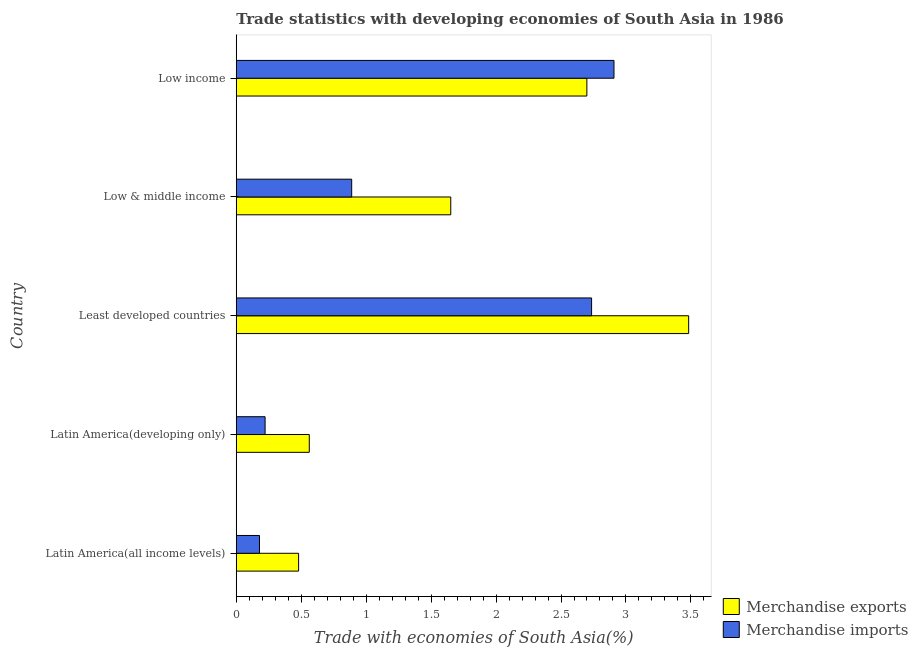Are the number of bars per tick equal to the number of legend labels?
Provide a short and direct response. Yes. Are the number of bars on each tick of the Y-axis equal?
Give a very brief answer. Yes. How many bars are there on the 5th tick from the bottom?
Your response must be concise. 2. What is the label of the 4th group of bars from the top?
Your answer should be compact. Latin America(developing only). What is the merchandise imports in Low income?
Your answer should be compact. 2.91. Across all countries, what is the maximum merchandise imports?
Make the answer very short. 2.91. Across all countries, what is the minimum merchandise imports?
Your answer should be compact. 0.18. In which country was the merchandise exports maximum?
Offer a very short reply. Least developed countries. In which country was the merchandise exports minimum?
Provide a short and direct response. Latin America(all income levels). What is the total merchandise imports in the graph?
Provide a succinct answer. 6.93. What is the difference between the merchandise exports in Least developed countries and that in Low income?
Your answer should be very brief. 0.78. What is the difference between the merchandise imports in Latin America(all income levels) and the merchandise exports in Low income?
Your answer should be very brief. -2.52. What is the average merchandise exports per country?
Offer a terse response. 1.77. What is the difference between the merchandise imports and merchandise exports in Latin America(all income levels)?
Provide a short and direct response. -0.3. In how many countries, is the merchandise imports greater than 2 %?
Your answer should be very brief. 2. What is the difference between the highest and the second highest merchandise imports?
Your answer should be compact. 0.17. What is the difference between the highest and the lowest merchandise imports?
Keep it short and to the point. 2.73. What does the 2nd bar from the top in Low & middle income represents?
Ensure brevity in your answer.  Merchandise exports. What does the 2nd bar from the bottom in Least developed countries represents?
Offer a terse response. Merchandise imports. How many bars are there?
Keep it short and to the point. 10. Are all the bars in the graph horizontal?
Give a very brief answer. Yes. How many countries are there in the graph?
Offer a terse response. 5. What is the difference between two consecutive major ticks on the X-axis?
Your response must be concise. 0.5. Are the values on the major ticks of X-axis written in scientific E-notation?
Your answer should be compact. No. Does the graph contain any zero values?
Provide a succinct answer. No. Does the graph contain grids?
Your answer should be compact. No. How many legend labels are there?
Your answer should be compact. 2. What is the title of the graph?
Your answer should be very brief. Trade statistics with developing economies of South Asia in 1986. What is the label or title of the X-axis?
Your answer should be very brief. Trade with economies of South Asia(%). What is the Trade with economies of South Asia(%) in Merchandise exports in Latin America(all income levels)?
Your response must be concise. 0.48. What is the Trade with economies of South Asia(%) in Merchandise imports in Latin America(all income levels)?
Your response must be concise. 0.18. What is the Trade with economies of South Asia(%) of Merchandise exports in Latin America(developing only)?
Make the answer very short. 0.56. What is the Trade with economies of South Asia(%) of Merchandise imports in Latin America(developing only)?
Your answer should be compact. 0.22. What is the Trade with economies of South Asia(%) of Merchandise exports in Least developed countries?
Offer a very short reply. 3.48. What is the Trade with economies of South Asia(%) of Merchandise imports in Least developed countries?
Make the answer very short. 2.74. What is the Trade with economies of South Asia(%) in Merchandise exports in Low & middle income?
Your answer should be compact. 1.65. What is the Trade with economies of South Asia(%) in Merchandise imports in Low & middle income?
Your answer should be very brief. 0.89. What is the Trade with economies of South Asia(%) of Merchandise exports in Low income?
Your response must be concise. 2.7. What is the Trade with economies of South Asia(%) of Merchandise imports in Low income?
Your response must be concise. 2.91. Across all countries, what is the maximum Trade with economies of South Asia(%) in Merchandise exports?
Offer a very short reply. 3.48. Across all countries, what is the maximum Trade with economies of South Asia(%) of Merchandise imports?
Provide a short and direct response. 2.91. Across all countries, what is the minimum Trade with economies of South Asia(%) in Merchandise exports?
Make the answer very short. 0.48. Across all countries, what is the minimum Trade with economies of South Asia(%) in Merchandise imports?
Keep it short and to the point. 0.18. What is the total Trade with economies of South Asia(%) of Merchandise exports in the graph?
Your answer should be very brief. 8.88. What is the total Trade with economies of South Asia(%) of Merchandise imports in the graph?
Ensure brevity in your answer.  6.93. What is the difference between the Trade with economies of South Asia(%) of Merchandise exports in Latin America(all income levels) and that in Latin America(developing only)?
Make the answer very short. -0.08. What is the difference between the Trade with economies of South Asia(%) in Merchandise imports in Latin America(all income levels) and that in Latin America(developing only)?
Ensure brevity in your answer.  -0.04. What is the difference between the Trade with economies of South Asia(%) of Merchandise exports in Latin America(all income levels) and that in Least developed countries?
Give a very brief answer. -3. What is the difference between the Trade with economies of South Asia(%) in Merchandise imports in Latin America(all income levels) and that in Least developed countries?
Offer a very short reply. -2.56. What is the difference between the Trade with economies of South Asia(%) of Merchandise exports in Latin America(all income levels) and that in Low & middle income?
Ensure brevity in your answer.  -1.17. What is the difference between the Trade with economies of South Asia(%) in Merchandise imports in Latin America(all income levels) and that in Low & middle income?
Make the answer very short. -0.71. What is the difference between the Trade with economies of South Asia(%) in Merchandise exports in Latin America(all income levels) and that in Low income?
Offer a very short reply. -2.22. What is the difference between the Trade with economies of South Asia(%) in Merchandise imports in Latin America(all income levels) and that in Low income?
Make the answer very short. -2.73. What is the difference between the Trade with economies of South Asia(%) of Merchandise exports in Latin America(developing only) and that in Least developed countries?
Your response must be concise. -2.92. What is the difference between the Trade with economies of South Asia(%) in Merchandise imports in Latin America(developing only) and that in Least developed countries?
Your answer should be very brief. -2.51. What is the difference between the Trade with economies of South Asia(%) in Merchandise exports in Latin America(developing only) and that in Low & middle income?
Give a very brief answer. -1.09. What is the difference between the Trade with economies of South Asia(%) in Merchandise imports in Latin America(developing only) and that in Low & middle income?
Provide a succinct answer. -0.67. What is the difference between the Trade with economies of South Asia(%) of Merchandise exports in Latin America(developing only) and that in Low income?
Make the answer very short. -2.14. What is the difference between the Trade with economies of South Asia(%) of Merchandise imports in Latin America(developing only) and that in Low income?
Offer a terse response. -2.69. What is the difference between the Trade with economies of South Asia(%) in Merchandise exports in Least developed countries and that in Low & middle income?
Provide a succinct answer. 1.83. What is the difference between the Trade with economies of South Asia(%) of Merchandise imports in Least developed countries and that in Low & middle income?
Make the answer very short. 1.85. What is the difference between the Trade with economies of South Asia(%) in Merchandise exports in Least developed countries and that in Low income?
Provide a succinct answer. 0.78. What is the difference between the Trade with economies of South Asia(%) of Merchandise imports in Least developed countries and that in Low income?
Keep it short and to the point. -0.17. What is the difference between the Trade with economies of South Asia(%) of Merchandise exports in Low & middle income and that in Low income?
Your answer should be very brief. -1.05. What is the difference between the Trade with economies of South Asia(%) of Merchandise imports in Low & middle income and that in Low income?
Keep it short and to the point. -2.02. What is the difference between the Trade with economies of South Asia(%) of Merchandise exports in Latin America(all income levels) and the Trade with economies of South Asia(%) of Merchandise imports in Latin America(developing only)?
Ensure brevity in your answer.  0.26. What is the difference between the Trade with economies of South Asia(%) in Merchandise exports in Latin America(all income levels) and the Trade with economies of South Asia(%) in Merchandise imports in Least developed countries?
Keep it short and to the point. -2.26. What is the difference between the Trade with economies of South Asia(%) of Merchandise exports in Latin America(all income levels) and the Trade with economies of South Asia(%) of Merchandise imports in Low & middle income?
Your answer should be compact. -0.41. What is the difference between the Trade with economies of South Asia(%) of Merchandise exports in Latin America(all income levels) and the Trade with economies of South Asia(%) of Merchandise imports in Low income?
Make the answer very short. -2.43. What is the difference between the Trade with economies of South Asia(%) of Merchandise exports in Latin America(developing only) and the Trade with economies of South Asia(%) of Merchandise imports in Least developed countries?
Your answer should be compact. -2.17. What is the difference between the Trade with economies of South Asia(%) in Merchandise exports in Latin America(developing only) and the Trade with economies of South Asia(%) in Merchandise imports in Low & middle income?
Your answer should be compact. -0.33. What is the difference between the Trade with economies of South Asia(%) of Merchandise exports in Latin America(developing only) and the Trade with economies of South Asia(%) of Merchandise imports in Low income?
Make the answer very short. -2.35. What is the difference between the Trade with economies of South Asia(%) of Merchandise exports in Least developed countries and the Trade with economies of South Asia(%) of Merchandise imports in Low & middle income?
Your answer should be very brief. 2.59. What is the difference between the Trade with economies of South Asia(%) in Merchandise exports in Least developed countries and the Trade with economies of South Asia(%) in Merchandise imports in Low income?
Give a very brief answer. 0.57. What is the difference between the Trade with economies of South Asia(%) in Merchandise exports in Low & middle income and the Trade with economies of South Asia(%) in Merchandise imports in Low income?
Offer a terse response. -1.26. What is the average Trade with economies of South Asia(%) of Merchandise exports per country?
Keep it short and to the point. 1.77. What is the average Trade with economies of South Asia(%) in Merchandise imports per country?
Offer a terse response. 1.39. What is the difference between the Trade with economies of South Asia(%) in Merchandise exports and Trade with economies of South Asia(%) in Merchandise imports in Latin America(all income levels)?
Your response must be concise. 0.3. What is the difference between the Trade with economies of South Asia(%) of Merchandise exports and Trade with economies of South Asia(%) of Merchandise imports in Latin America(developing only)?
Ensure brevity in your answer.  0.34. What is the difference between the Trade with economies of South Asia(%) of Merchandise exports and Trade with economies of South Asia(%) of Merchandise imports in Least developed countries?
Your answer should be compact. 0.75. What is the difference between the Trade with economies of South Asia(%) in Merchandise exports and Trade with economies of South Asia(%) in Merchandise imports in Low & middle income?
Your response must be concise. 0.76. What is the difference between the Trade with economies of South Asia(%) of Merchandise exports and Trade with economies of South Asia(%) of Merchandise imports in Low income?
Offer a very short reply. -0.21. What is the ratio of the Trade with economies of South Asia(%) in Merchandise exports in Latin America(all income levels) to that in Latin America(developing only)?
Provide a short and direct response. 0.85. What is the ratio of the Trade with economies of South Asia(%) in Merchandise imports in Latin America(all income levels) to that in Latin America(developing only)?
Make the answer very short. 0.81. What is the ratio of the Trade with economies of South Asia(%) of Merchandise exports in Latin America(all income levels) to that in Least developed countries?
Give a very brief answer. 0.14. What is the ratio of the Trade with economies of South Asia(%) of Merchandise imports in Latin America(all income levels) to that in Least developed countries?
Offer a very short reply. 0.07. What is the ratio of the Trade with economies of South Asia(%) of Merchandise exports in Latin America(all income levels) to that in Low & middle income?
Make the answer very short. 0.29. What is the ratio of the Trade with economies of South Asia(%) of Merchandise imports in Latin America(all income levels) to that in Low & middle income?
Your answer should be compact. 0.2. What is the ratio of the Trade with economies of South Asia(%) in Merchandise exports in Latin America(all income levels) to that in Low income?
Provide a short and direct response. 0.18. What is the ratio of the Trade with economies of South Asia(%) in Merchandise imports in Latin America(all income levels) to that in Low income?
Offer a very short reply. 0.06. What is the ratio of the Trade with economies of South Asia(%) in Merchandise exports in Latin America(developing only) to that in Least developed countries?
Keep it short and to the point. 0.16. What is the ratio of the Trade with economies of South Asia(%) in Merchandise imports in Latin America(developing only) to that in Least developed countries?
Ensure brevity in your answer.  0.08. What is the ratio of the Trade with economies of South Asia(%) in Merchandise exports in Latin America(developing only) to that in Low & middle income?
Your response must be concise. 0.34. What is the ratio of the Trade with economies of South Asia(%) in Merchandise imports in Latin America(developing only) to that in Low & middle income?
Offer a terse response. 0.25. What is the ratio of the Trade with economies of South Asia(%) in Merchandise exports in Latin America(developing only) to that in Low income?
Offer a terse response. 0.21. What is the ratio of the Trade with economies of South Asia(%) of Merchandise imports in Latin America(developing only) to that in Low income?
Your response must be concise. 0.08. What is the ratio of the Trade with economies of South Asia(%) of Merchandise exports in Least developed countries to that in Low & middle income?
Offer a very short reply. 2.11. What is the ratio of the Trade with economies of South Asia(%) of Merchandise imports in Least developed countries to that in Low & middle income?
Make the answer very short. 3.08. What is the ratio of the Trade with economies of South Asia(%) in Merchandise exports in Least developed countries to that in Low income?
Give a very brief answer. 1.29. What is the ratio of the Trade with economies of South Asia(%) in Merchandise imports in Least developed countries to that in Low income?
Give a very brief answer. 0.94. What is the ratio of the Trade with economies of South Asia(%) in Merchandise exports in Low & middle income to that in Low income?
Keep it short and to the point. 0.61. What is the ratio of the Trade with economies of South Asia(%) of Merchandise imports in Low & middle income to that in Low income?
Your answer should be compact. 0.31. What is the difference between the highest and the second highest Trade with economies of South Asia(%) of Merchandise exports?
Make the answer very short. 0.78. What is the difference between the highest and the second highest Trade with economies of South Asia(%) of Merchandise imports?
Your response must be concise. 0.17. What is the difference between the highest and the lowest Trade with economies of South Asia(%) of Merchandise exports?
Your answer should be very brief. 3. What is the difference between the highest and the lowest Trade with economies of South Asia(%) in Merchandise imports?
Give a very brief answer. 2.73. 